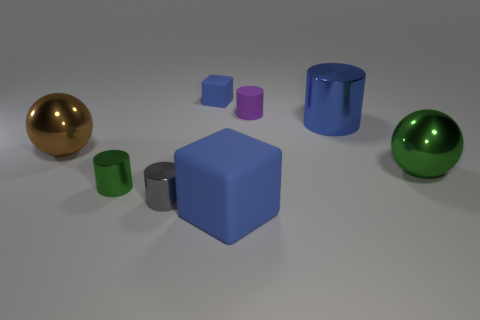Imagine if this scene had natural lighting, how would shadows be cast by these objects? If there were natural lighting, such as from the sun, the objects would cast shadows that correspond to their shapes. For instance, the spheres would cast circular shadows, the cylinder would cast an elongated shadow, and the cubes would cast square-shaped shadows, with the direction and length of the shadows depending on the angle of the light source. 